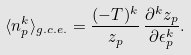Convert formula to latex. <formula><loc_0><loc_0><loc_500><loc_500>\langle n ^ { k } _ { p } \rangle _ { g . c . e . } = \frac { ( - T ) ^ { k } } { z _ { p } } \, \frac { \partial ^ { k } z _ { p } } { \partial \epsilon _ { p } ^ { k } } .</formula> 